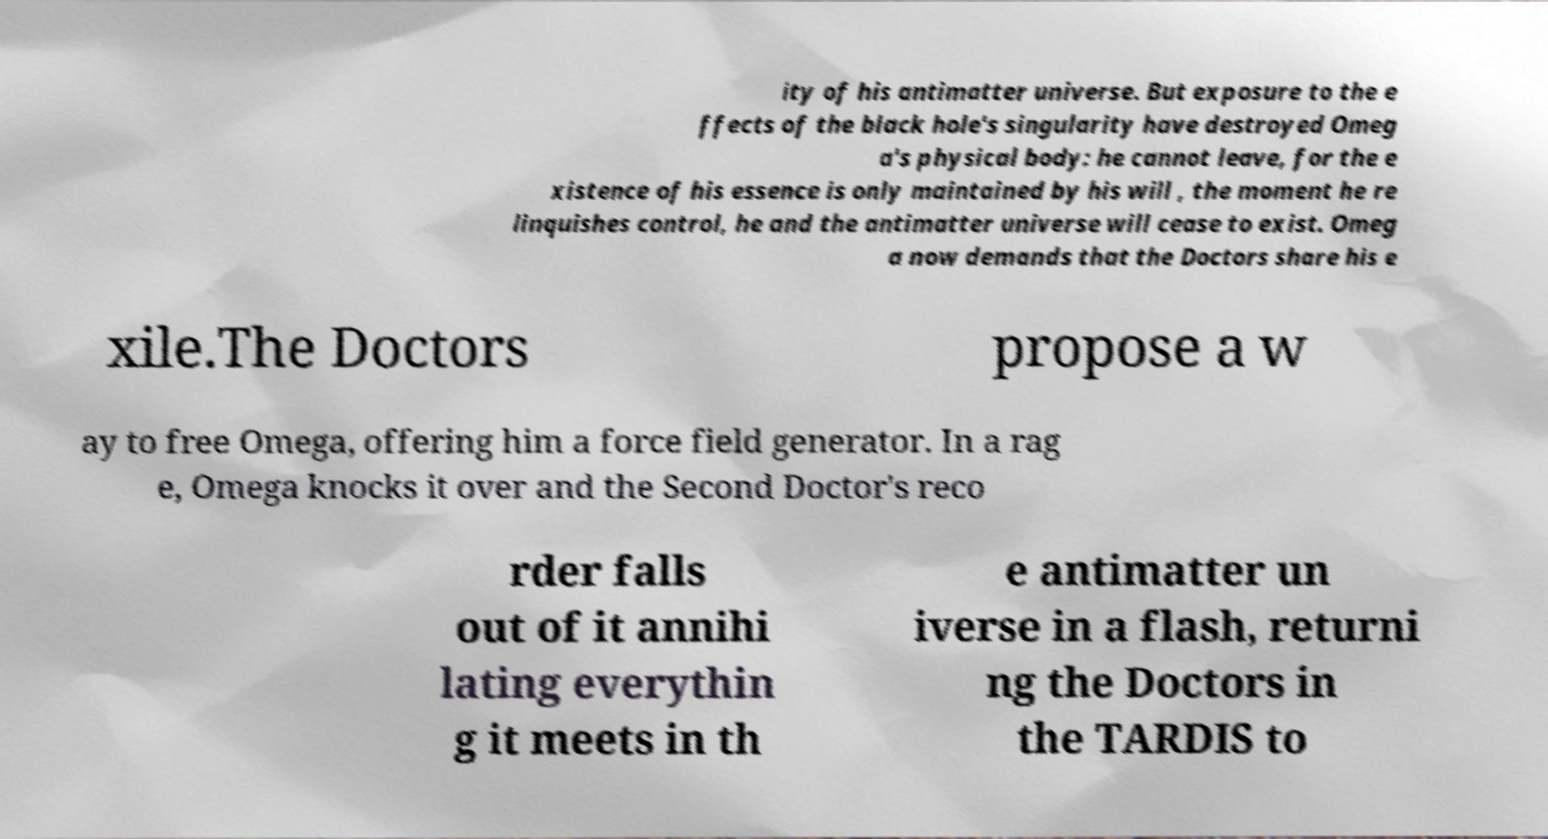What messages or text are displayed in this image? I need them in a readable, typed format. ity of his antimatter universe. But exposure to the e ffects of the black hole's singularity have destroyed Omeg a's physical body: he cannot leave, for the e xistence of his essence is only maintained by his will , the moment he re linquishes control, he and the antimatter universe will cease to exist. Omeg a now demands that the Doctors share his e xile.The Doctors propose a w ay to free Omega, offering him a force field generator. In a rag e, Omega knocks it over and the Second Doctor's reco rder falls out of it annihi lating everythin g it meets in th e antimatter un iverse in a flash, returni ng the Doctors in the TARDIS to 